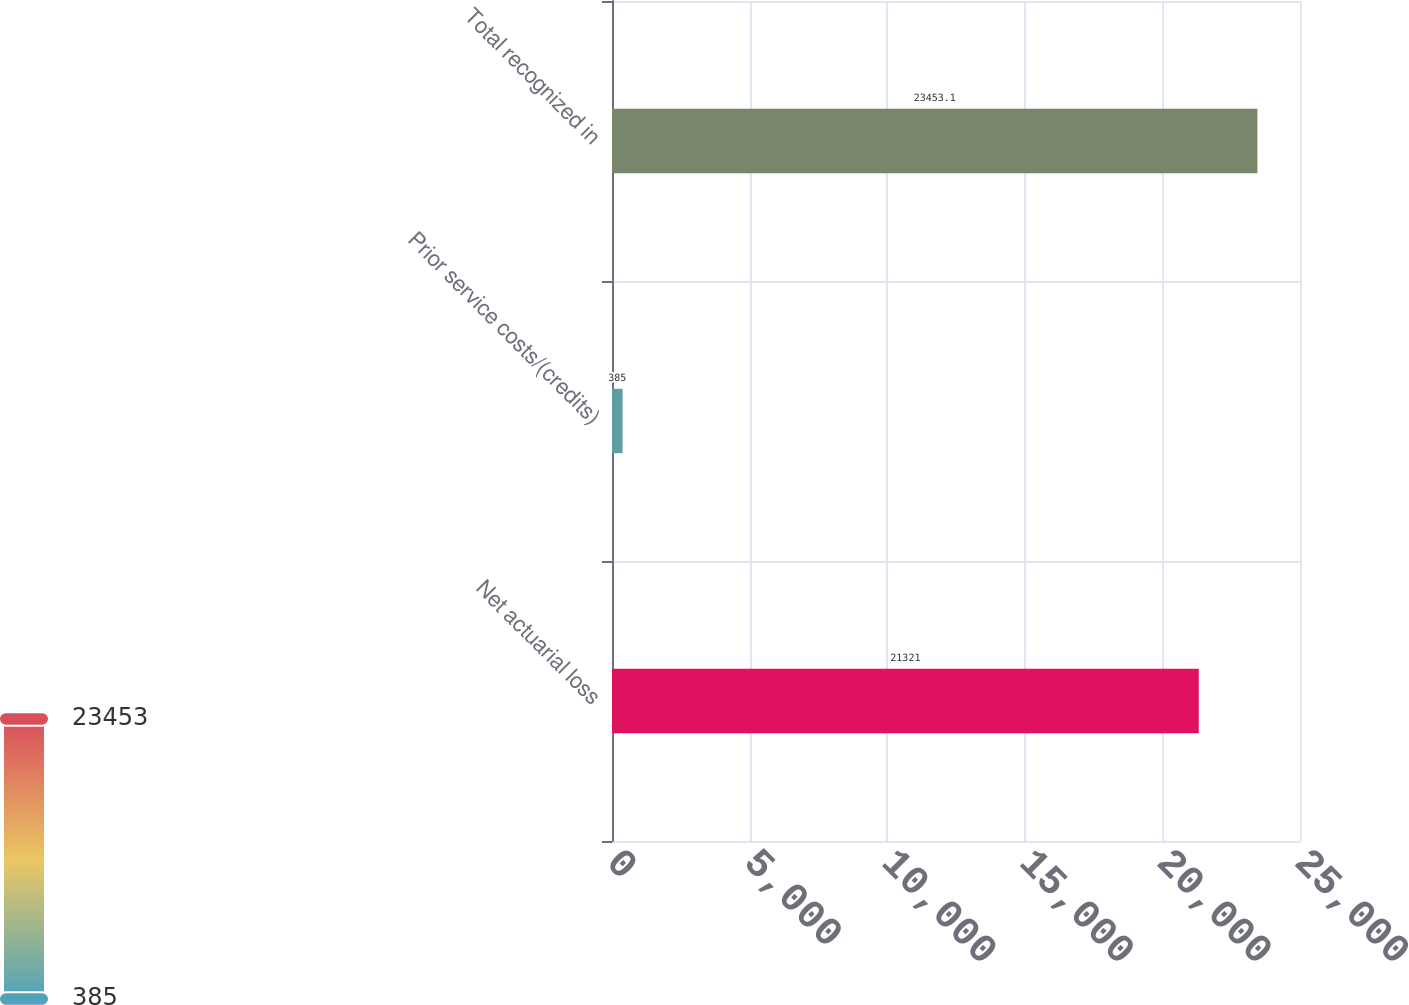Convert chart to OTSL. <chart><loc_0><loc_0><loc_500><loc_500><bar_chart><fcel>Net actuarial loss<fcel>Prior service costs/(credits)<fcel>Total recognized in<nl><fcel>21321<fcel>385<fcel>23453.1<nl></chart> 